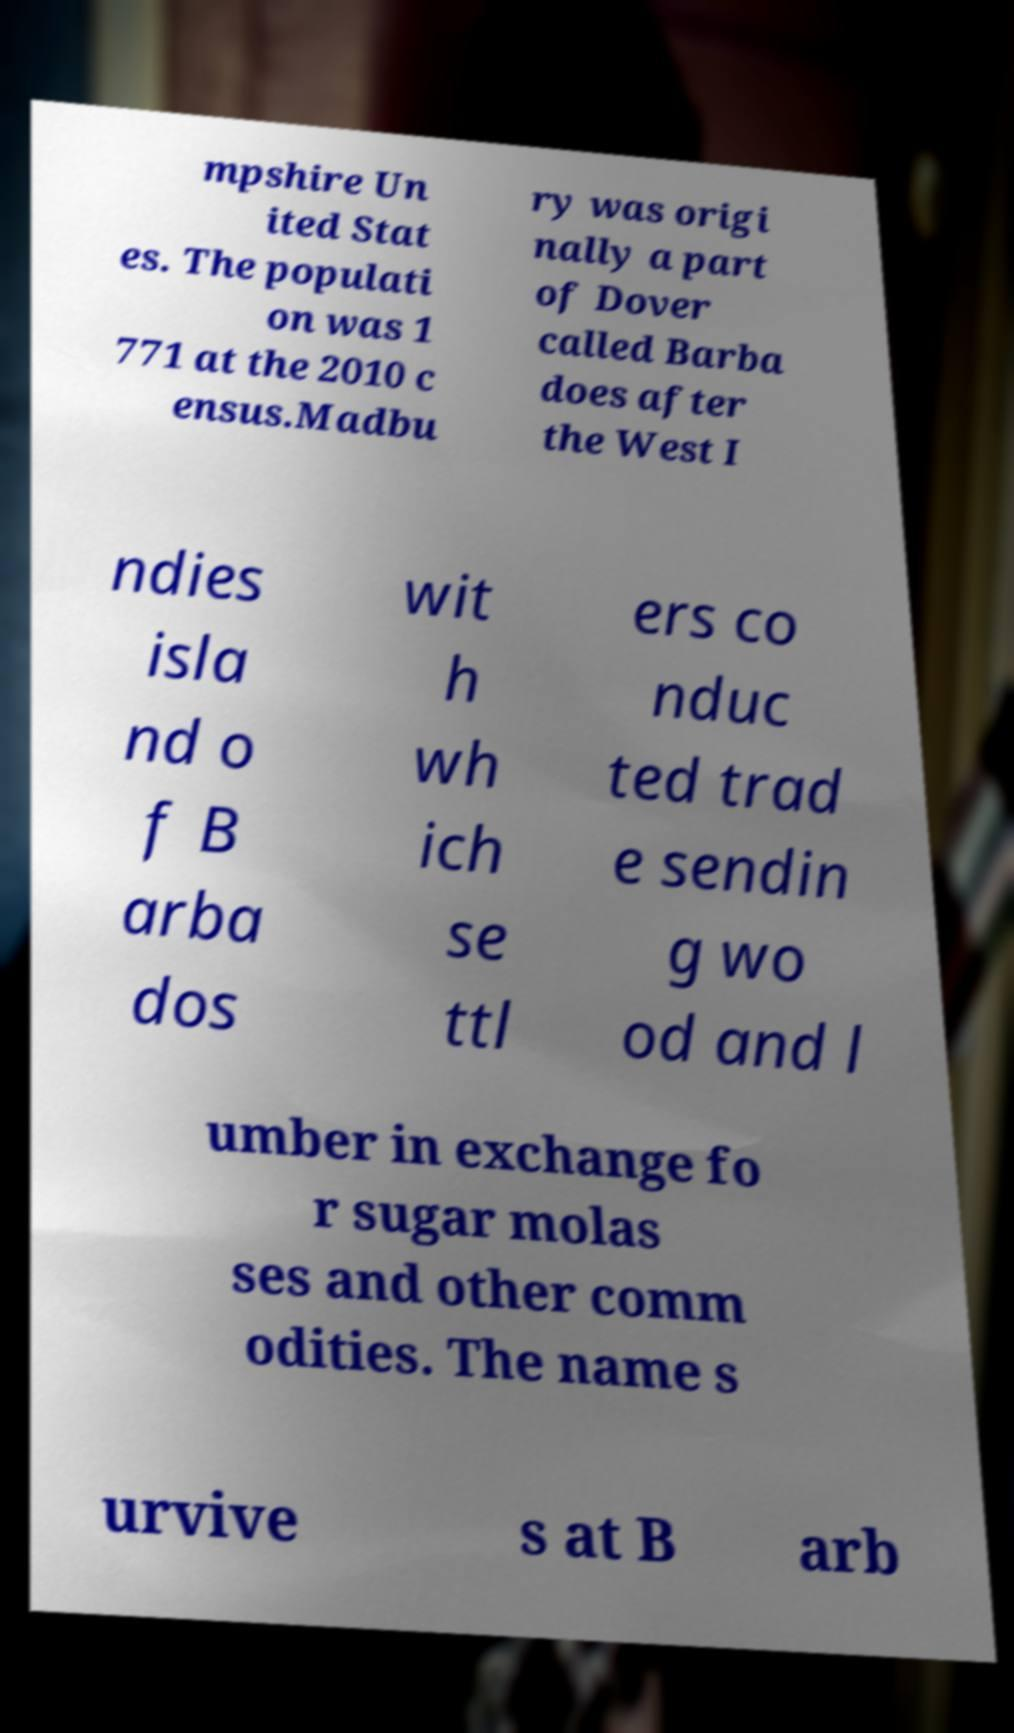There's text embedded in this image that I need extracted. Can you transcribe it verbatim? mpshire Un ited Stat es. The populati on was 1 771 at the 2010 c ensus.Madbu ry was origi nally a part of Dover called Barba does after the West I ndies isla nd o f B arba dos wit h wh ich se ttl ers co nduc ted trad e sendin g wo od and l umber in exchange fo r sugar molas ses and other comm odities. The name s urvive s at B arb 